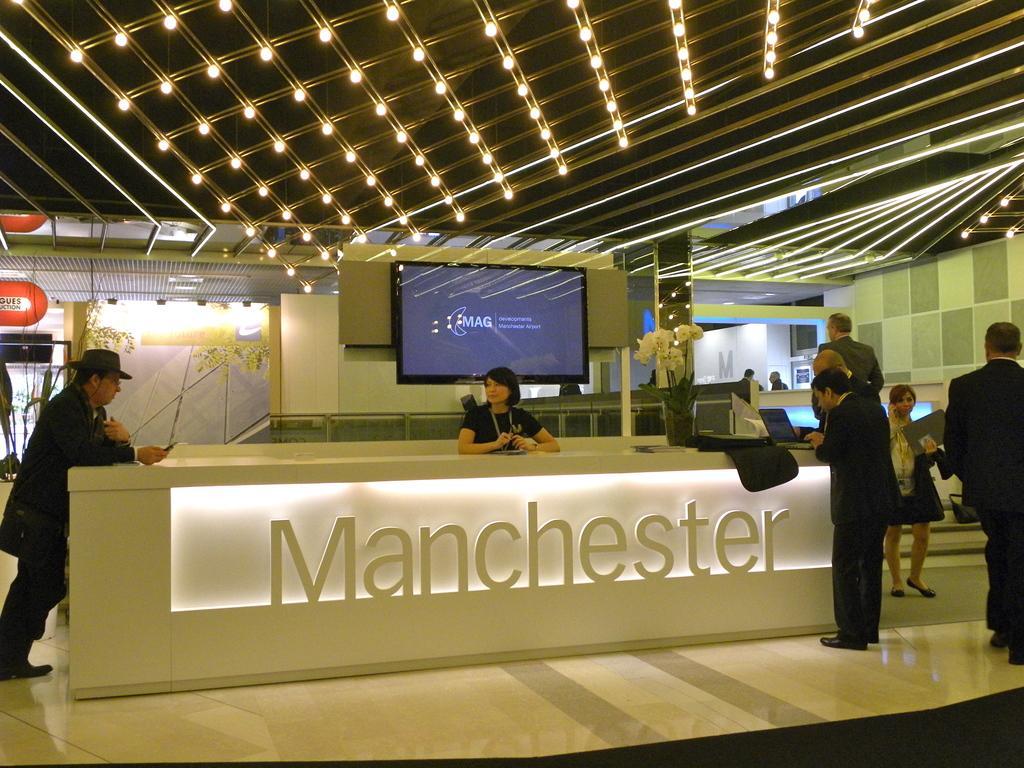In one or two sentences, can you explain what this image depicts? This is an inside view. In the middle of this image I can see a table, at the back I can see a woman is looking at the man who is standing on the left side. On the right side I can see some people are standing and few are working on laptops. On the table I can see a flower vase. In the background there is a screen is attached to the wall and also there are some lights. On the top of the image I can see few more lights. 